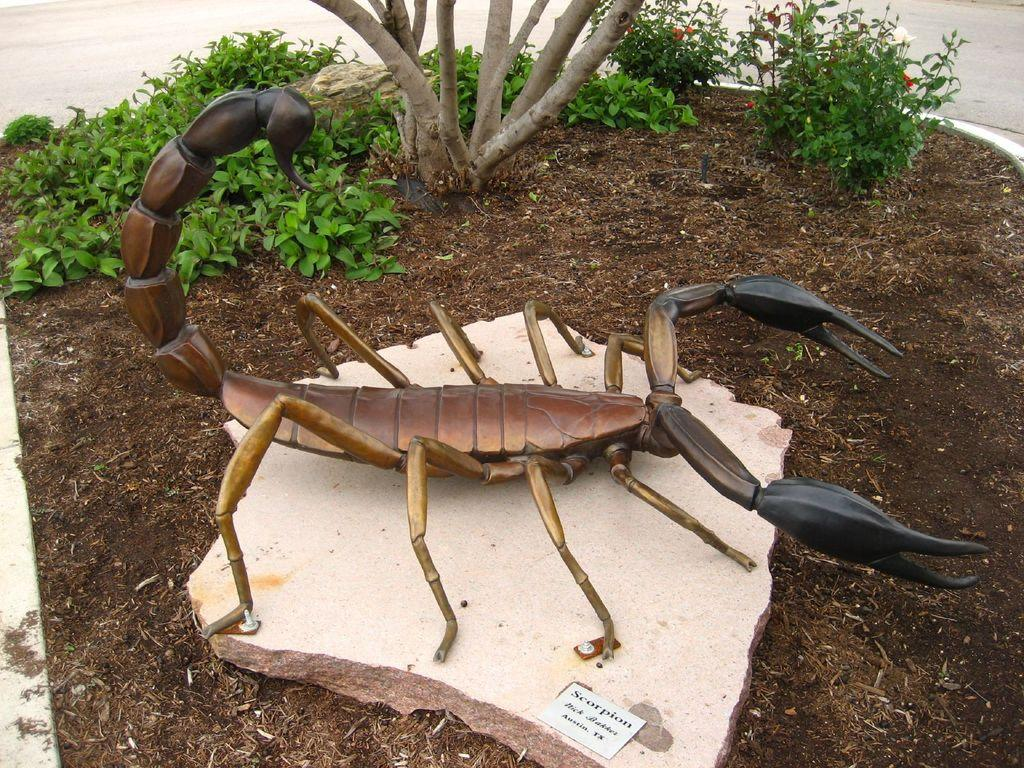What is the main subject of the image? The main subject of the image is a crab statue. What is the crab statue placed on? The crab statue is on a stone. What can be seen in the background of the image? There are small plants in the background of the image. How are the small plants arranged in the image? The small plants are planted in the soil. What type of chain is wrapped around the crab statue in the image? There is no chain wrapped around the crab statue in the image. What mineral can be seen sparkling in the sunlight in the image? There is no mineral or sunlight present in the image; it features a crab statue on a stone with small plants in the background. 